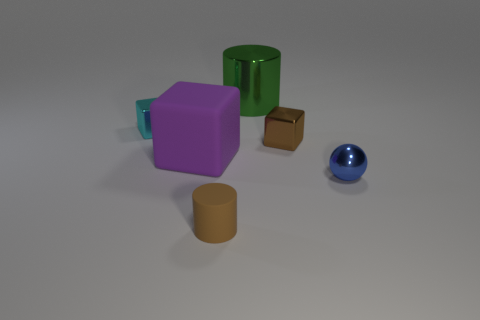There is another object that is the same shape as the large metallic object; what is its material?
Offer a terse response. Rubber. What number of other large things have the same shape as the cyan shiny thing?
Provide a succinct answer. 1. There is a brown object that is behind the small brown object that is in front of the large purple thing; what is its material?
Offer a very short reply. Metal. There is a small metallic thing that is the same color as the matte cylinder; what is its shape?
Your answer should be compact. Cube. Is there a small ball made of the same material as the brown block?
Ensure brevity in your answer.  Yes. What is the shape of the green shiny thing?
Give a very brief answer. Cylinder. How many small blue balls are there?
Make the answer very short. 1. The metal cube on the right side of the small brown thing in front of the metal ball is what color?
Make the answer very short. Brown. There is a matte cylinder that is the same size as the cyan metallic thing; what is its color?
Your response must be concise. Brown. Is there a tiny shiny object of the same color as the tiny rubber thing?
Your response must be concise. Yes. 